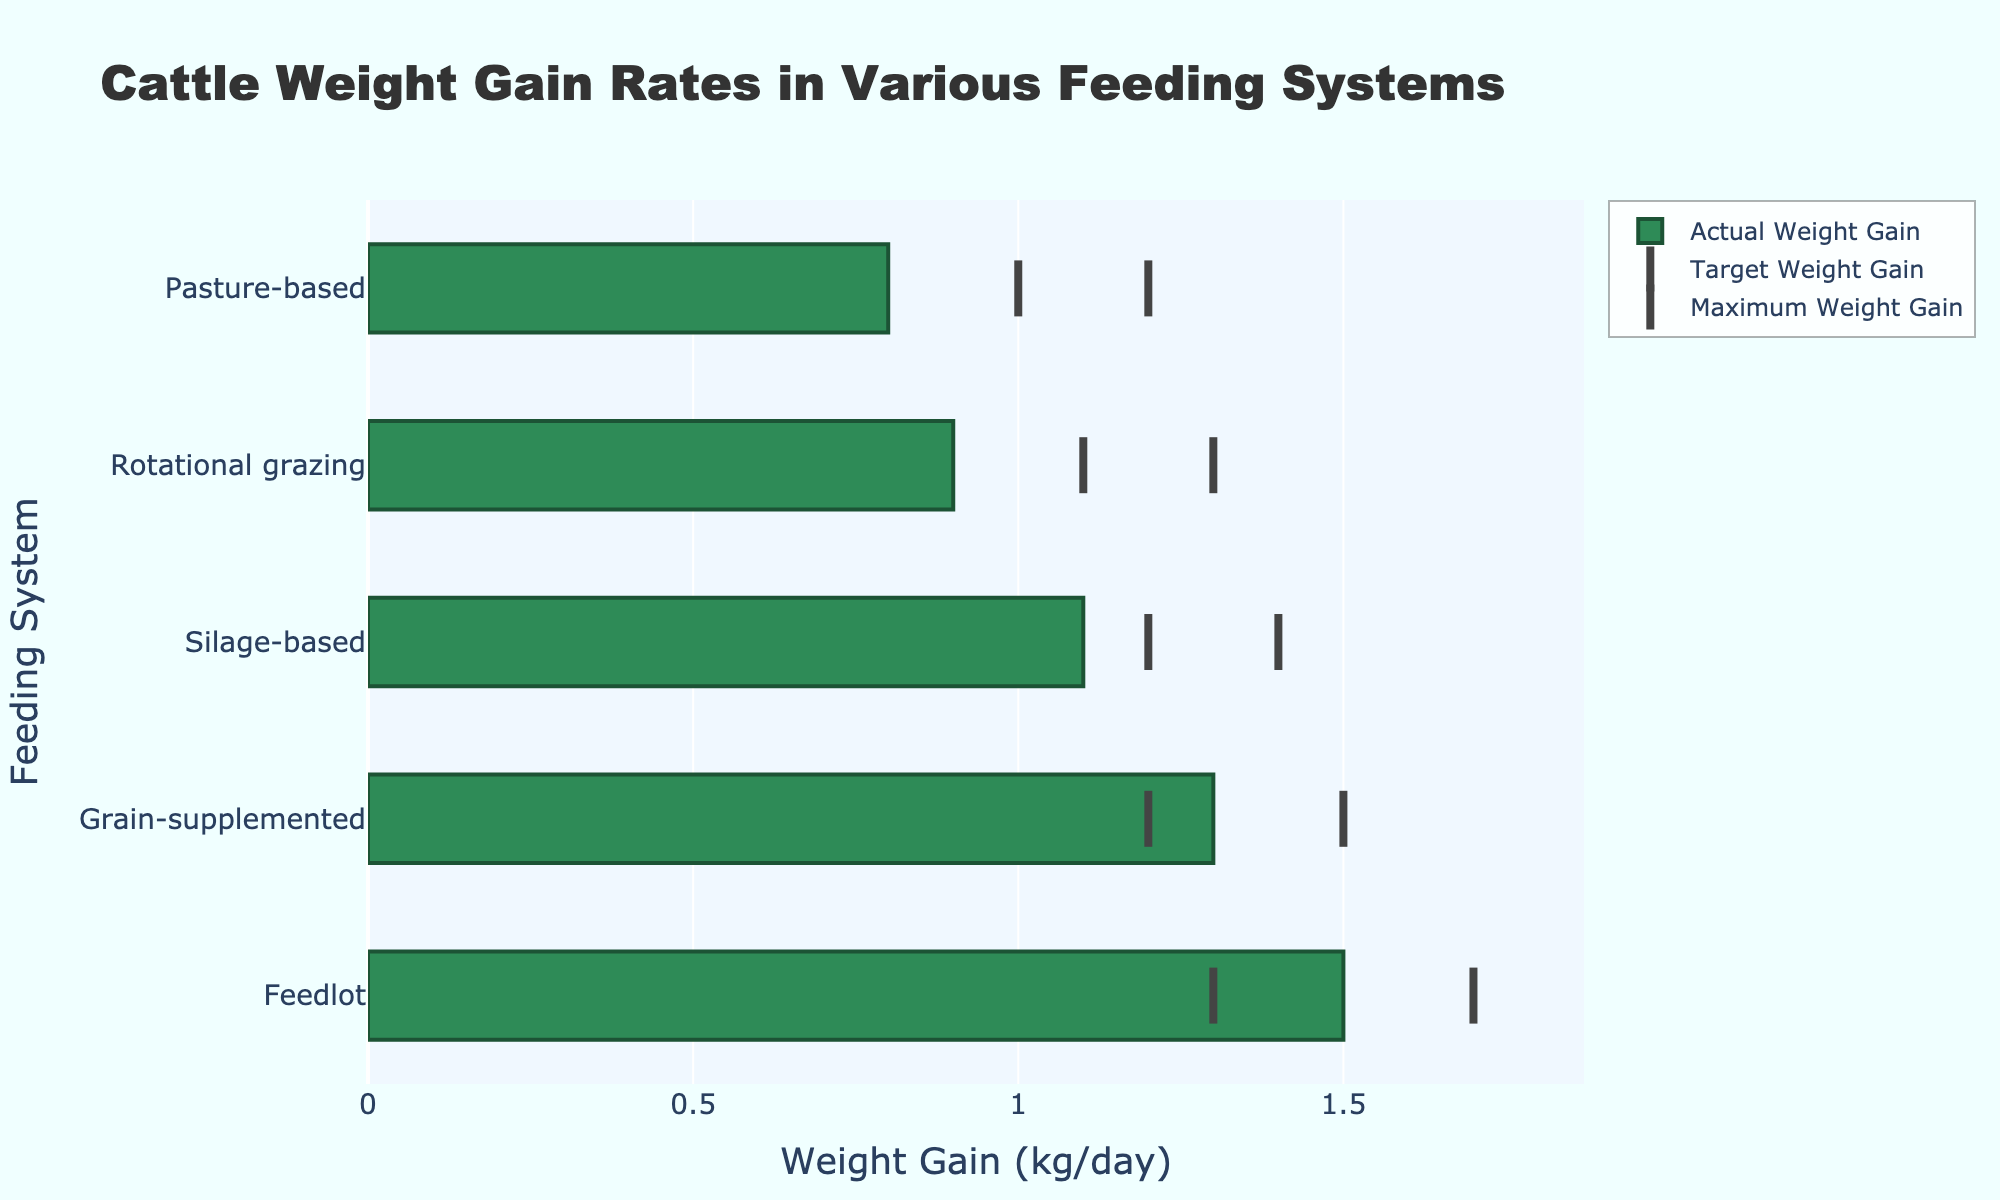What's the title of the figure? The title is located at the top of the figure and indicates the main topic it addresses. Look at the largest text located centrally at the top of the plot.
Answer: "Cattle Weight Gain Rates in Various Feeding Systems" Which feeding system has the highest actual weight gain rate? Locate the bars representing the actual weight gain rates. The bar extending furthest to the right represents the highest actual weight gain rate.
Answer: Feedlot What is the target weight gain rate for the Pasture-based feeding system? Identify the Pasture-based feeding system and locate the yellow marker (representing the target weight gain rate) on that row.
Answer: 1.0 kg/day How much greater is the actual weight gain rate in the Feedlot system compared to the Pasture-based system? Find the actual weight gain rates for both Feedlot and Pasture-based systems from the horizontal bars. Subtract the Pasture-based rate from the Feedlot rate.
Answer: 0.7 kg/day Are there any feeding systems where the actual weight gain rate equals the target weight gain rate? Compare the positions of the horizontal bars (actual weight gain rates) with the yellow markers (target weight gain rates) for each feeding system. No system's bar aligns exactly with its target marker.
Answer: No Which feeding system exceeds its target weight gain by the largest margin? For each feeding system, find the difference between the actual weight gain rate (bar) and the target weight gain rate (yellow marker). The system with the largest positive difference is the answer.
Answer: Feedlot Does any feeding system achieve the maximum weight gain rate? Check the position of the red markers (maximum weight gain rates) relative to the actual weight gain bars. None of the bars reach their corresponding red marker.
Answer: No How does the actual weight gain rate for Rotational grazing compare to its target and maximum rates? For Rotational grazing, compare the actual weight gain bar to the yellow (target) and red (maximum) markers. The actual rate is less than both the target and maximum rates.
Answer: Less than both What is the range of actual weight gain rates across all feeding systems? Identify the minimum and maximum actual weight gain rates from the bars representing each system. Subtract the minimum rate from the maximum rate.
Answer: 1.5 kg/day Which feeding systems have actual weight gain rates below their target rates? Identify systems where the horizontal bar (actual rate) is shorter than the yellow marker (target rate). The systems are Pasture-based, Silage-based, and Rotational grazing.
Answer: Pasture-based, Silage-based, Rotational grazing 